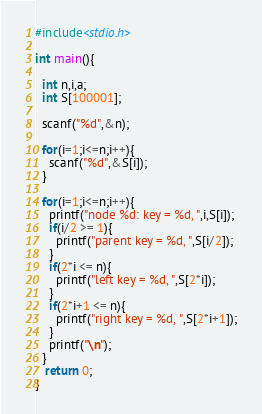<code> <loc_0><loc_0><loc_500><loc_500><_C_>#include<stdio.h>

int main(){

  int n,i,a;
  int S[100001];
  
  scanf("%d",&n);

  for(i=1;i<=n;i++){
    scanf("%d",&S[i]);
  }

  for(i=1;i<=n;i++){
    printf("node %d: key = %d, ",i,S[i]);
    if(i/2 >= 1){
      printf("parent key = %d, ",S[i/2]);
    }
    if(2*i <= n){
      printf("left key = %d, ",S[2*i]);
    }
    if(2*i+1 <= n){
      printf("right key = %d, ",S[2*i+1]);
    }
    printf("\n");
  }
   return 0;
}</code> 